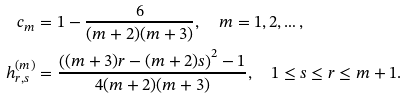Convert formula to latex. <formula><loc_0><loc_0><loc_500><loc_500>c _ { m } & = 1 - \frac { 6 } { ( m + 2 ) ( m + 3 ) } , \quad m = 1 , 2 , \dots , \\ h ^ { ( m ) } _ { r , s } & = \frac { \left ( ( m + 3 ) r - ( m + 2 ) s \right ) ^ { 2 } - 1 } { 4 ( m + 2 ) ( m + 3 ) } , \quad 1 \leq s \leq r \leq m + 1 .</formula> 